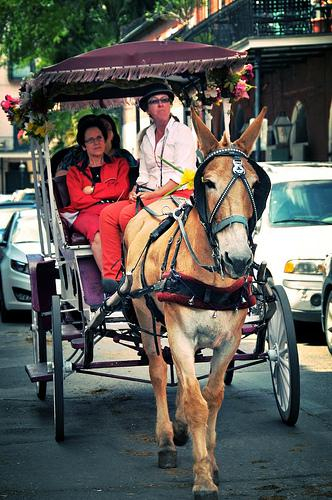Question: what kind of animal is this?
Choices:
A. A horse.
B. A mule.
C. A sheep.
D. A donkey.
Answer with the letter. Answer: D Question: how many people are there?
Choices:
A. Two.
B. Three.
C. Four.
D. Five.
Answer with the letter. Answer: B Question: where is the woman in red?
Choices:
A. In a plane.
B. In the carriage.
C. In a car.
D. In a wheelchair.
Answer with the letter. Answer: B Question: who is in the photo?
Choices:
A. Two women.
B. One woman.
C. Three women.
D. Four women.
Answer with the letter. Answer: C Question: when was the photo taken?
Choices:
A. Nighttime.
B. Dusk.
C. Dawn.
D. Daytime.
Answer with the letter. Answer: D 